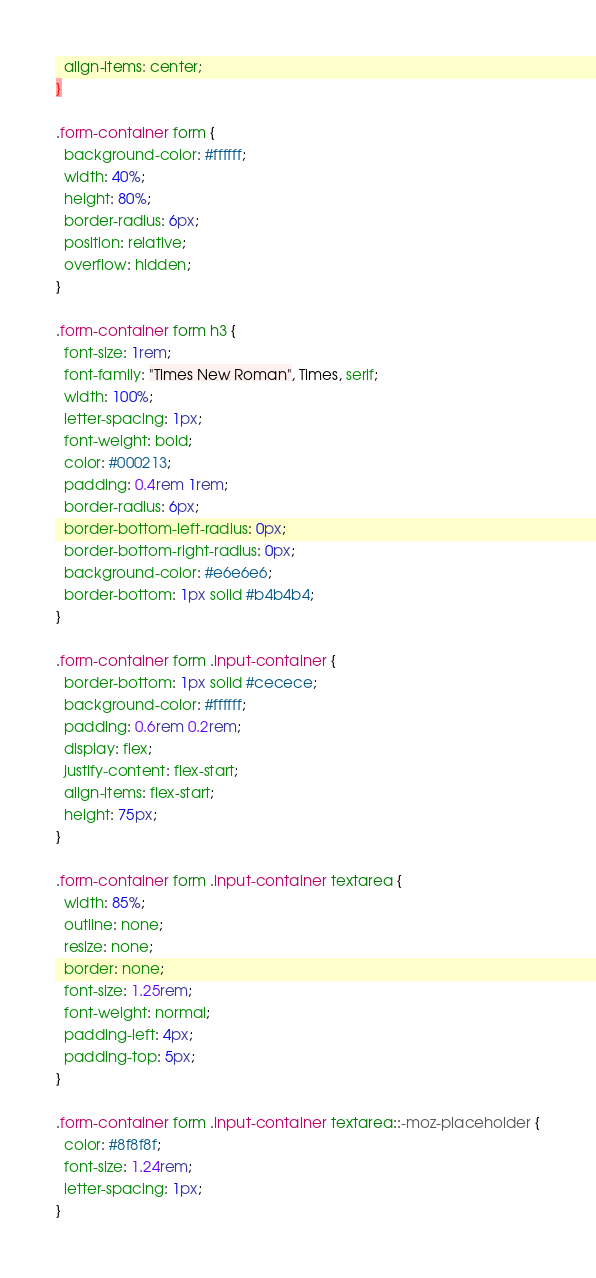Convert code to text. <code><loc_0><loc_0><loc_500><loc_500><_CSS_>  align-items: center;
}

.form-container form {
  background-color: #ffffff;
  width: 40%;
  height: 80%;
  border-radius: 6px;
  position: relative;
  overflow: hidden;
}

.form-container form h3 {
  font-size: 1rem;
  font-family: "Times New Roman", Times, serif;
  width: 100%;
  letter-spacing: 1px;
  font-weight: bold;
  color: #000213;
  padding: 0.4rem 1rem;
  border-radius: 6px;
  border-bottom-left-radius: 0px;
  border-bottom-right-radius: 0px;
  background-color: #e6e6e6;
  border-bottom: 1px solid #b4b4b4;
}

.form-container form .input-container {
  border-bottom: 1px solid #cecece;
  background-color: #ffffff;
  padding: 0.6rem 0.2rem;
  display: flex;
  justify-content: flex-start;
  align-items: flex-start;
  height: 75px;
}

.form-container form .input-container textarea {
  width: 85%;
  outline: none;
  resize: none;
  border: none;
  font-size: 1.25rem;
  font-weight: normal;
  padding-left: 4px;
  padding-top: 5px;
}

.form-container form .input-container textarea::-moz-placeholder {
  color: #8f8f8f;
  font-size: 1.24rem;
  letter-spacing: 1px;
}
</code> 